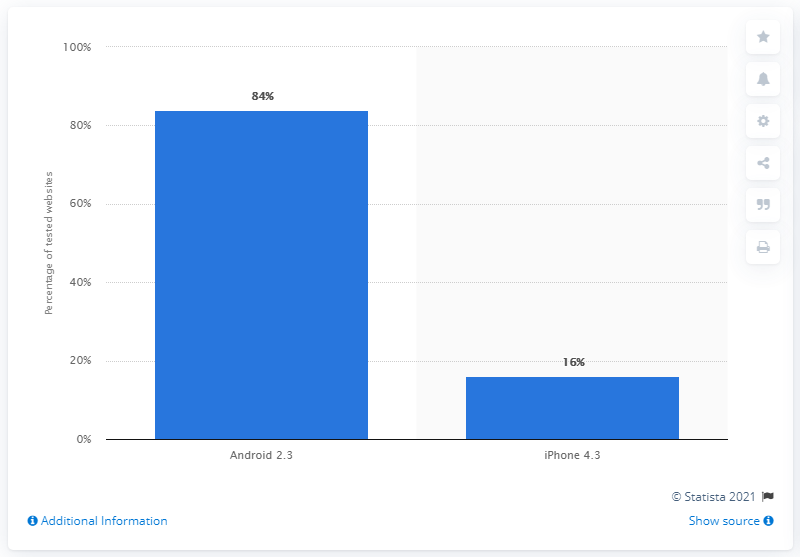Outline some significant characteristics in this image. The iPhone 4.3 has a smaller percentage compared to the operating system of another device. Which operating system has a larger percentage, Android 2.3 or iOS 8? 